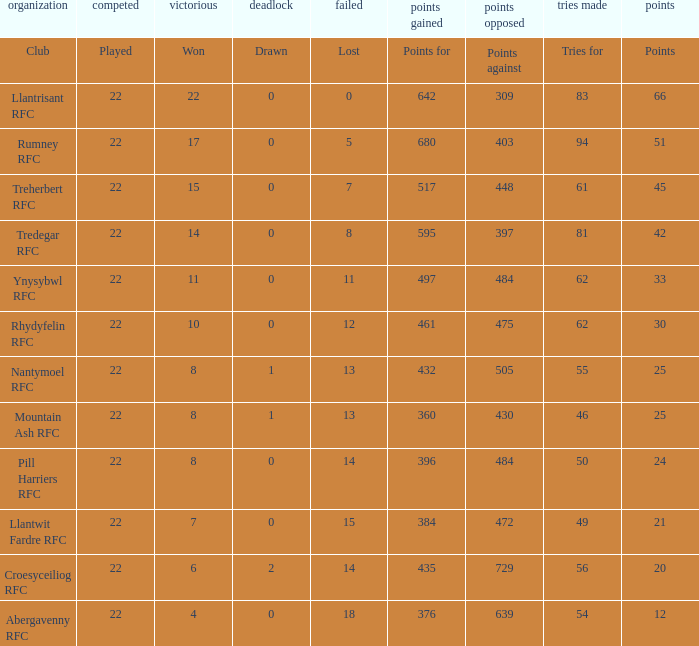Which club lost exactly 7 matches? Treherbert RFC. 